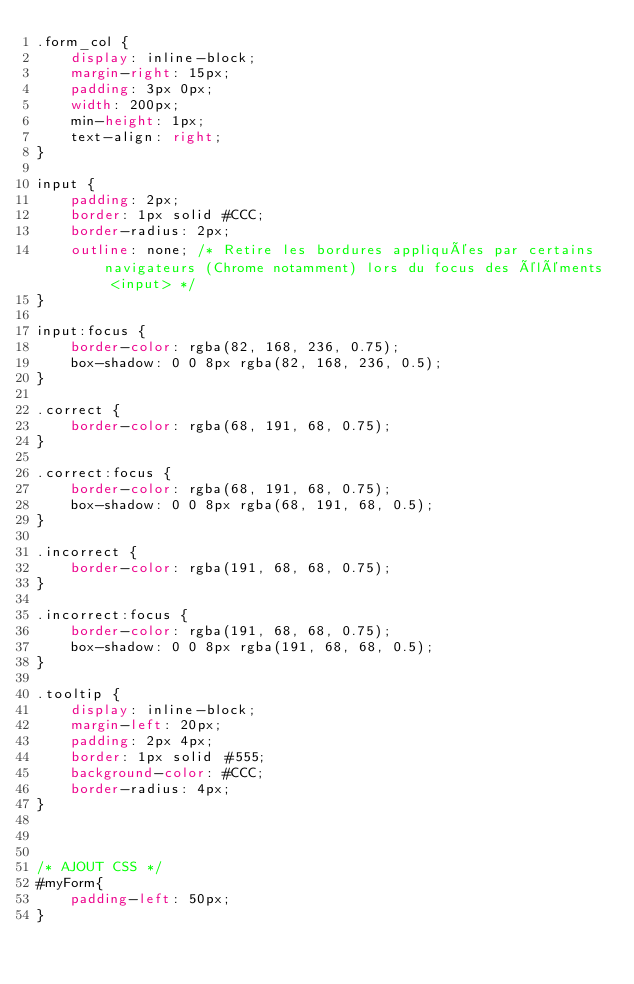<code> <loc_0><loc_0><loc_500><loc_500><_CSS_>.form_col {
    display: inline-block;
    margin-right: 15px;
    padding: 3px 0px;
    width: 200px;
    min-height: 1px;
    text-align: right;
}
	
input {
	padding: 2px;
	border: 1px solid #CCC;
	border-radius: 2px;
	outline: none; /* Retire les bordures appliquées par certains navigateurs (Chrome notamment) lors du focus des éléments <input> */
}
	
input:focus {
	border-color: rgba(82, 168, 236, 0.75);
	box-shadow: 0 0 8px rgba(82, 168, 236, 0.5);
}
	
.correct {
	border-color: rgba(68, 191, 68, 0.75);
}
	
.correct:focus {
	border-color: rgba(68, 191, 68, 0.75);
	box-shadow: 0 0 8px rgba(68, 191, 68, 0.5);
}
	
.incorrect {
	border-color: rgba(191, 68, 68, 0.75);
}
	
.incorrect:focus {
	border-color: rgba(191, 68, 68, 0.75);
	box-shadow: 0 0 8px rgba(191, 68, 68, 0.5);
}
	
.tooltip {
	display: inline-block;
	margin-left: 20px;
	padding: 2px 4px;
	border: 1px solid #555;
	background-color: #CCC;
	border-radius: 4px;
}



/* AJOUT CSS */
#myForm{
    padding-left: 50px;
}</code> 